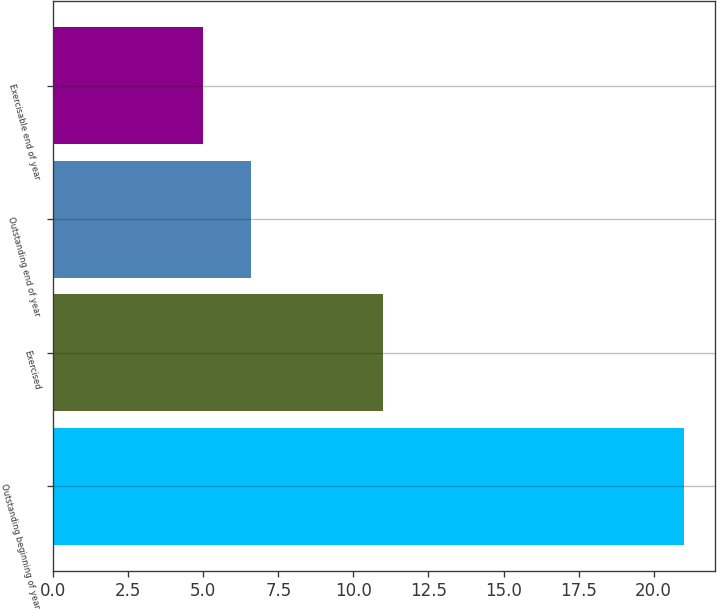<chart> <loc_0><loc_0><loc_500><loc_500><bar_chart><fcel>Outstanding beginning of year<fcel>Exercised<fcel>Outstanding end of year<fcel>Exercisable end of year<nl><fcel>21<fcel>11<fcel>6.6<fcel>5<nl></chart> 